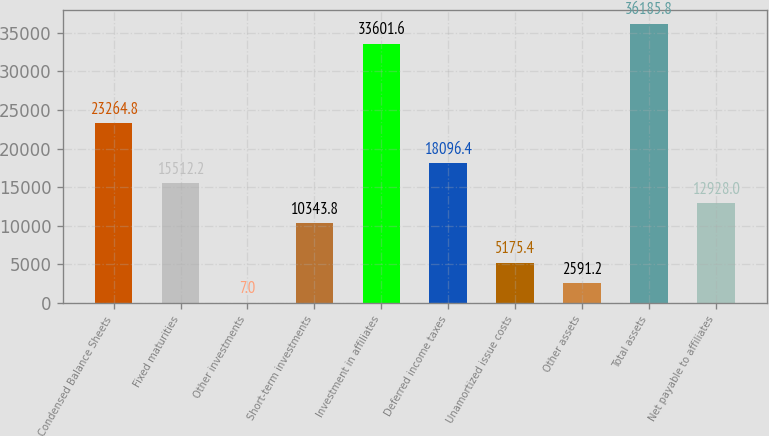Convert chart. <chart><loc_0><loc_0><loc_500><loc_500><bar_chart><fcel>Condensed Balance Sheets<fcel>Fixed maturities<fcel>Other investments<fcel>Short-term investments<fcel>Investment in affiliates<fcel>Deferred income taxes<fcel>Unamortized issue costs<fcel>Other assets<fcel>Total assets<fcel>Net payable to affiliates<nl><fcel>23264.8<fcel>15512.2<fcel>7<fcel>10343.8<fcel>33601.6<fcel>18096.4<fcel>5175.4<fcel>2591.2<fcel>36185.8<fcel>12928<nl></chart> 